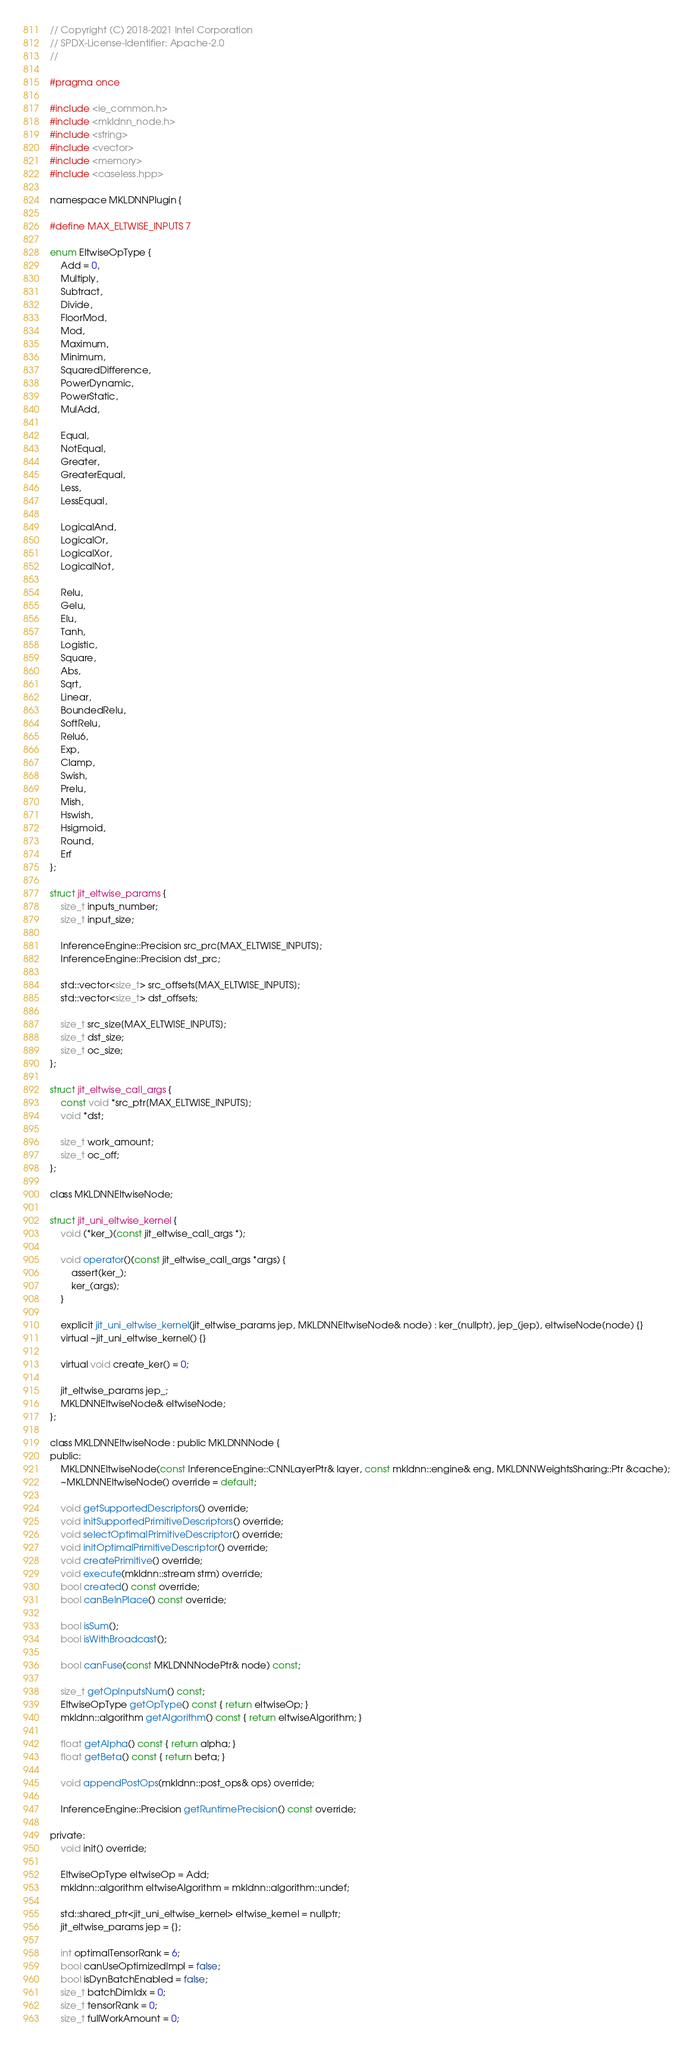<code> <loc_0><loc_0><loc_500><loc_500><_C_>// Copyright (C) 2018-2021 Intel Corporation
// SPDX-License-Identifier: Apache-2.0
//

#pragma once

#include <ie_common.h>
#include <mkldnn_node.h>
#include <string>
#include <vector>
#include <memory>
#include <caseless.hpp>

namespace MKLDNNPlugin {

#define MAX_ELTWISE_INPUTS 7

enum EltwiseOpType {
    Add = 0,
    Multiply,
    Subtract,
    Divide,
    FloorMod,
    Mod,
    Maximum,
    Minimum,
    SquaredDifference,
    PowerDynamic,
    PowerStatic,
    MulAdd,

    Equal,
    NotEqual,
    Greater,
    GreaterEqual,
    Less,
    LessEqual,

    LogicalAnd,
    LogicalOr,
    LogicalXor,
    LogicalNot,

    Relu,
    Gelu,
    Elu,
    Tanh,
    Logistic,
    Square,
    Abs,
    Sqrt,
    Linear,
    BoundedRelu,
    SoftRelu,
    Relu6,
    Exp,
    Clamp,
    Swish,
    Prelu,
    Mish,
    Hswish,
    Hsigmoid,
    Round,
    Erf
};

struct jit_eltwise_params {
    size_t inputs_number;
    size_t input_size;

    InferenceEngine::Precision src_prc[MAX_ELTWISE_INPUTS];
    InferenceEngine::Precision dst_prc;

    std::vector<size_t> src_offsets[MAX_ELTWISE_INPUTS];
    std::vector<size_t> dst_offsets;

    size_t src_size[MAX_ELTWISE_INPUTS];
    size_t dst_size;
    size_t oc_size;
};

struct jit_eltwise_call_args {
    const void *src_ptr[MAX_ELTWISE_INPUTS];
    void *dst;

    size_t work_amount;
    size_t oc_off;
};

class MKLDNNEltwiseNode;

struct jit_uni_eltwise_kernel {
    void (*ker_)(const jit_eltwise_call_args *);

    void operator()(const jit_eltwise_call_args *args) {
        assert(ker_);
        ker_(args);
    }

    explicit jit_uni_eltwise_kernel(jit_eltwise_params jep, MKLDNNEltwiseNode& node) : ker_(nullptr), jep_(jep), eltwiseNode(node) {}
    virtual ~jit_uni_eltwise_kernel() {}

    virtual void create_ker() = 0;

    jit_eltwise_params jep_;
    MKLDNNEltwiseNode& eltwiseNode;
};

class MKLDNNEltwiseNode : public MKLDNNNode {
public:
    MKLDNNEltwiseNode(const InferenceEngine::CNNLayerPtr& layer, const mkldnn::engine& eng, MKLDNNWeightsSharing::Ptr &cache);
    ~MKLDNNEltwiseNode() override = default;

    void getSupportedDescriptors() override;
    void initSupportedPrimitiveDescriptors() override;
    void selectOptimalPrimitiveDescriptor() override;
    void initOptimalPrimitiveDescriptor() override;
    void createPrimitive() override;
    void execute(mkldnn::stream strm) override;
    bool created() const override;
    bool canBeInPlace() const override;

    bool isSum();
    bool isWithBroadcast();

    bool canFuse(const MKLDNNNodePtr& node) const;

    size_t getOpInputsNum() const;
    EltwiseOpType getOpType() const { return eltwiseOp; }
    mkldnn::algorithm getAlgorithm() const { return eltwiseAlgorithm; }

    float getAlpha() const { return alpha; }
    float getBeta() const { return beta; }

    void appendPostOps(mkldnn::post_ops& ops) override;

    InferenceEngine::Precision getRuntimePrecision() const override;

private:
    void init() override;

    EltwiseOpType eltwiseOp = Add;
    mkldnn::algorithm eltwiseAlgorithm = mkldnn::algorithm::undef;

    std::shared_ptr<jit_uni_eltwise_kernel> eltwise_kernel = nullptr;
    jit_eltwise_params jep = {};

    int optimalTensorRank = 6;
    bool canUseOptimizedImpl = false;
    bool isDynBatchEnabled = false;
    size_t batchDimIdx = 0;
    size_t tensorRank = 0;
    size_t fullWorkAmount = 0;</code> 